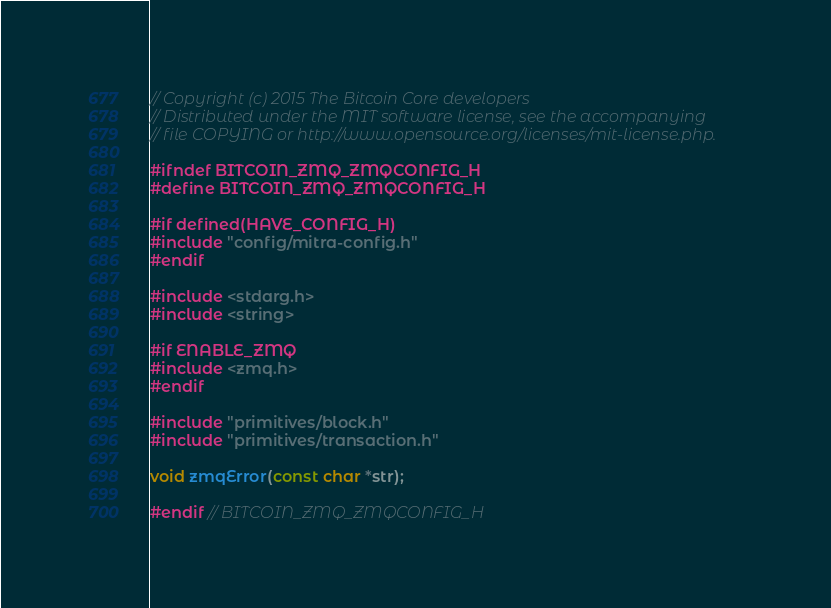<code> <loc_0><loc_0><loc_500><loc_500><_C_>// Copyright (c) 2015 The Bitcoin Core developers
// Distributed under the MIT software license, see the accompanying
// file COPYING or http://www.opensource.org/licenses/mit-license.php.

#ifndef BITCOIN_ZMQ_ZMQCONFIG_H
#define BITCOIN_ZMQ_ZMQCONFIG_H

#if defined(HAVE_CONFIG_H)
#include "config/mitra-config.h"
#endif

#include <stdarg.h>
#include <string>

#if ENABLE_ZMQ
#include <zmq.h>
#endif

#include "primitives/block.h"
#include "primitives/transaction.h"

void zmqError(const char *str);

#endif // BITCOIN_ZMQ_ZMQCONFIG_H
</code> 